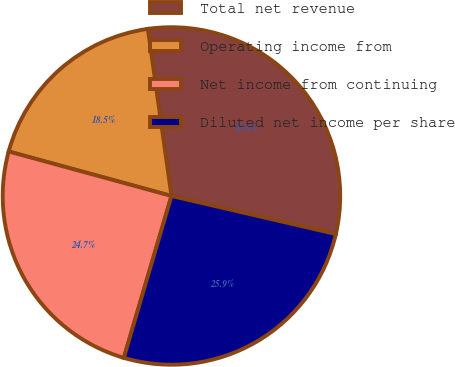Convert chart. <chart><loc_0><loc_0><loc_500><loc_500><pie_chart><fcel>Total net revenue<fcel>Operating income from<fcel>Net income from continuing<fcel>Diluted net income per share<nl><fcel>30.86%<fcel>18.52%<fcel>24.69%<fcel>25.93%<nl></chart> 